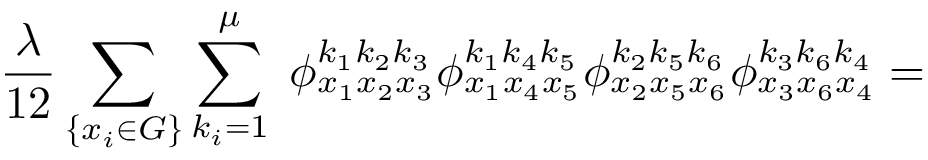Convert formula to latex. <formula><loc_0><loc_0><loc_500><loc_500>\frac { \lambda } { 1 2 } \sum _ { \{ x _ { i } \in G \} } \sum _ { k _ { i } = 1 } ^ { \mu } \, \phi _ { x _ { 1 } x _ { 2 } x _ { 3 } } ^ { k _ { 1 } k _ { 2 } k _ { 3 } } \phi _ { x _ { 1 } x _ { 4 } x _ { 5 } } ^ { k _ { 1 } k _ { 4 } k _ { 5 } } \phi _ { x _ { 2 } x _ { 5 } x _ { 6 } } ^ { k _ { 2 } k _ { 5 } k _ { 6 } } \phi _ { x _ { 3 } x _ { 6 } x _ { 4 } } ^ { k _ { 3 } k _ { 6 } k _ { 4 } } =</formula> 